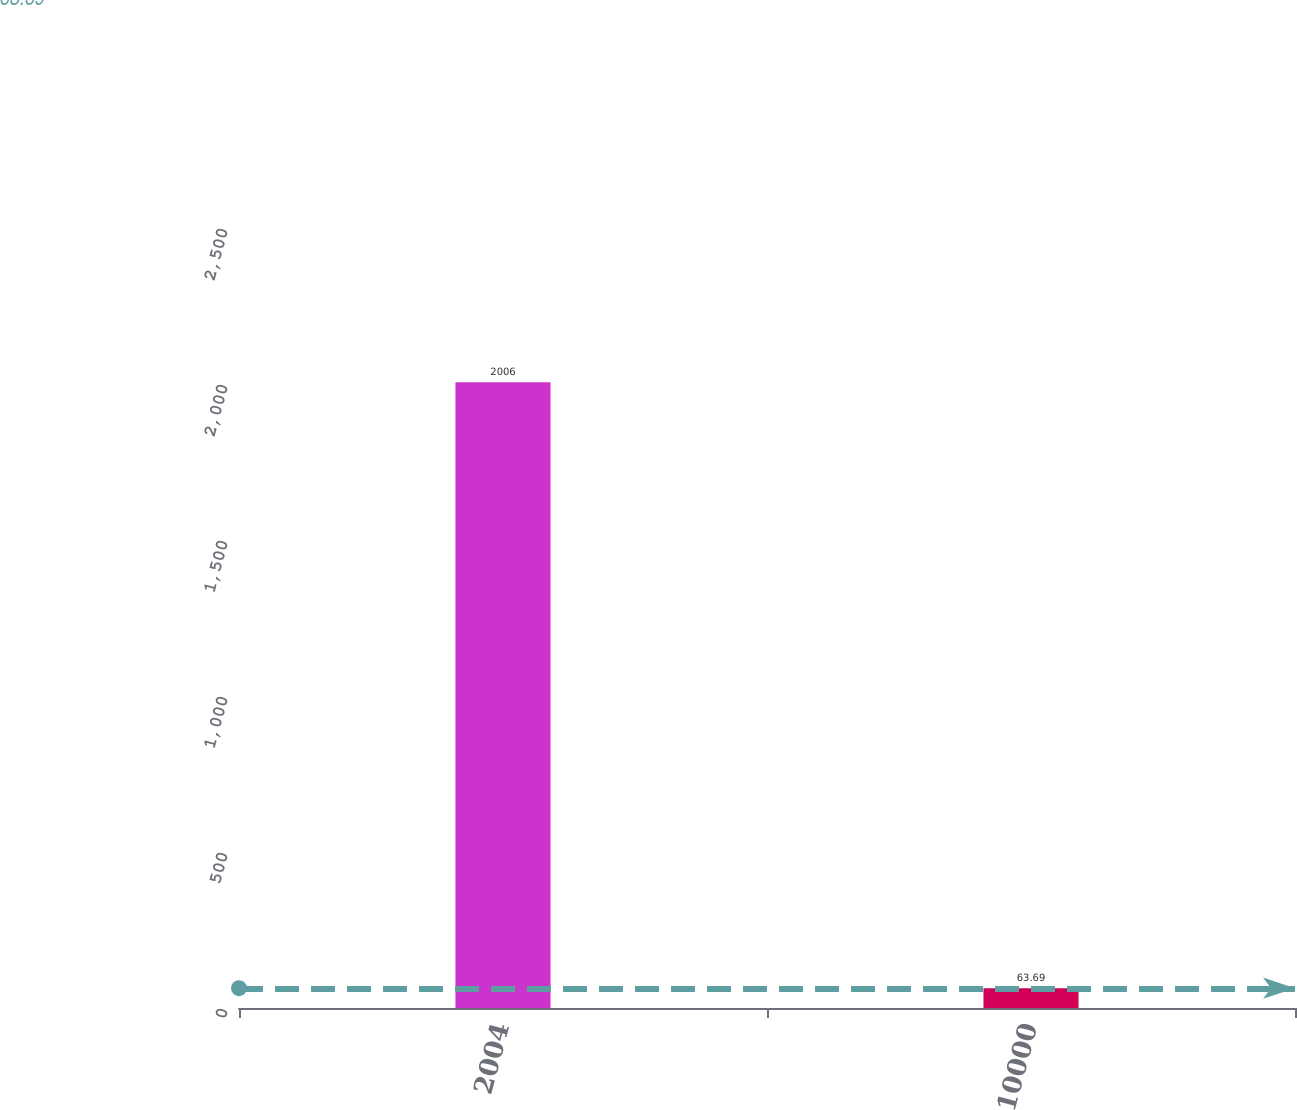Convert chart. <chart><loc_0><loc_0><loc_500><loc_500><bar_chart><fcel>2004<fcel>10000<nl><fcel>2006<fcel>63.69<nl></chart> 